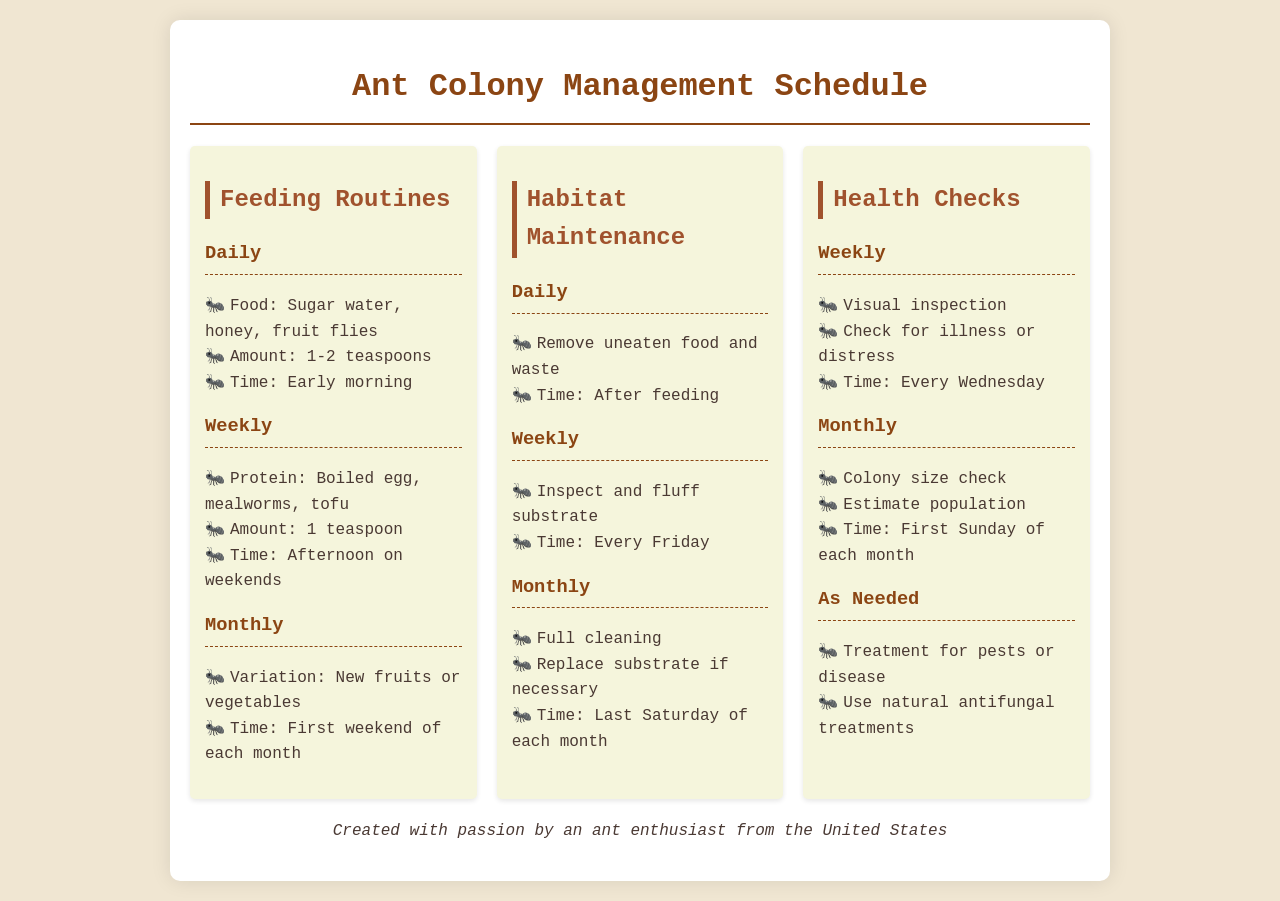What is the daily food for the ants? The daily food includes sugar water, honey, and fruit flies.
Answer: sugar water, honey, fruit flies How much protein should be fed weekly? The weekly protein amount is specified as 1 teaspoon.
Answer: 1 teaspoon When is the full cleaning scheduled? The full cleaning is scheduled for the last Saturday of each month.
Answer: last Saturday of each month What time are health checks performed weekly? The health checks are performed every Wednesday.
Answer: every Wednesday What is checked during the monthly health checks? The monthly health checks include a colony size check and population estimate.
Answer: colony size check, estimate population How often should the substrate be inspected? The substrate should be inspected weekly.
Answer: weekly What is removed daily from the habitat? Uneaten food and waste are removed daily.
Answer: uneaten food and waste When should new fruits or vegetables be introduced? New fruits or vegetables should be introduced on the first weekend of each month.
Answer: first weekend of each month What type of treatment is used for pests or disease? Natural antifungal treatments are used for pests or disease.
Answer: natural antifungal treatments 